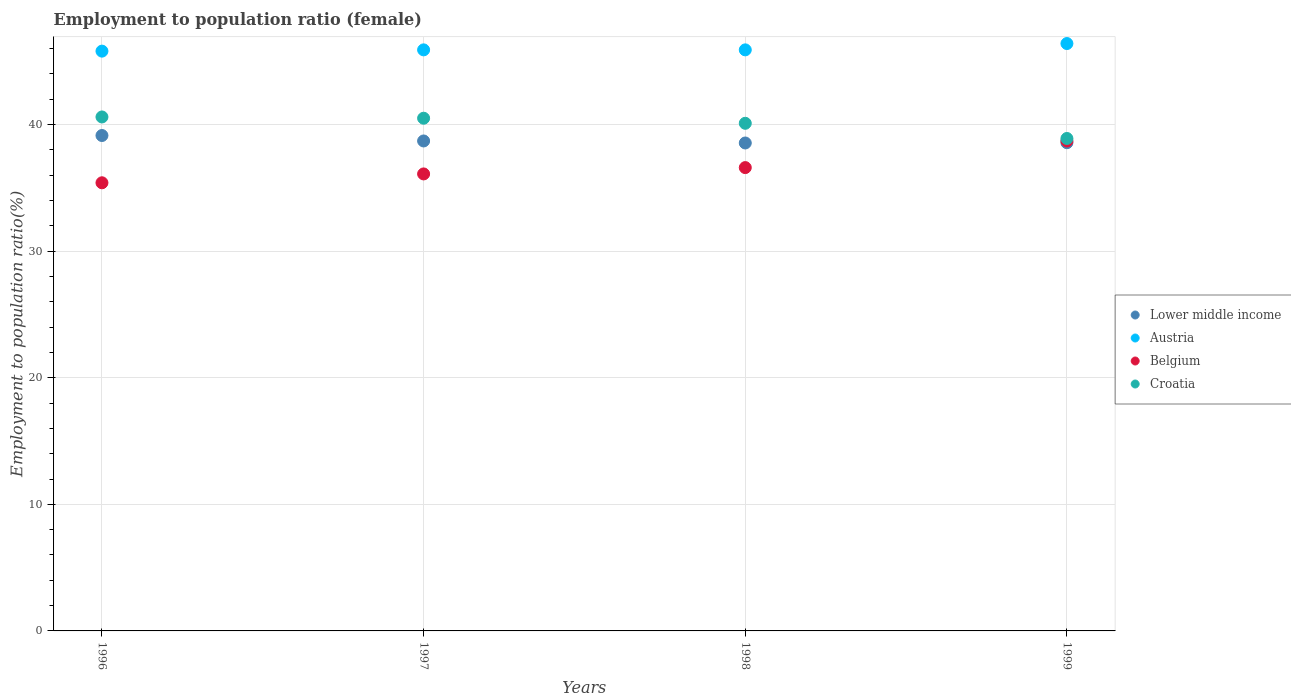What is the employment to population ratio in Croatia in 1998?
Provide a succinct answer. 40.1. Across all years, what is the maximum employment to population ratio in Belgium?
Provide a short and direct response. 38.7. Across all years, what is the minimum employment to population ratio in Lower middle income?
Make the answer very short. 38.54. In which year was the employment to population ratio in Belgium minimum?
Provide a short and direct response. 1996. What is the total employment to population ratio in Lower middle income in the graph?
Keep it short and to the point. 154.95. What is the difference between the employment to population ratio in Austria in 1998 and that in 1999?
Your answer should be very brief. -0.5. What is the difference between the employment to population ratio in Lower middle income in 1998 and the employment to population ratio in Croatia in 1997?
Keep it short and to the point. -1.96. What is the average employment to population ratio in Croatia per year?
Keep it short and to the point. 40.02. In the year 1996, what is the difference between the employment to population ratio in Lower middle income and employment to population ratio in Belgium?
Give a very brief answer. 3.73. What is the ratio of the employment to population ratio in Croatia in 1996 to that in 1999?
Offer a very short reply. 1.04. What is the difference between the highest and the second highest employment to population ratio in Croatia?
Your response must be concise. 0.1. What is the difference between the highest and the lowest employment to population ratio in Croatia?
Make the answer very short. 1.7. In how many years, is the employment to population ratio in Croatia greater than the average employment to population ratio in Croatia taken over all years?
Provide a short and direct response. 3. Is it the case that in every year, the sum of the employment to population ratio in Lower middle income and employment to population ratio in Belgium  is greater than the sum of employment to population ratio in Croatia and employment to population ratio in Austria?
Your answer should be very brief. Yes. Does the employment to population ratio in Lower middle income monotonically increase over the years?
Make the answer very short. No. Is the employment to population ratio in Belgium strictly greater than the employment to population ratio in Lower middle income over the years?
Offer a terse response. No. Is the employment to population ratio in Lower middle income strictly less than the employment to population ratio in Croatia over the years?
Your answer should be compact. Yes. How many dotlines are there?
Your answer should be compact. 4. Are the values on the major ticks of Y-axis written in scientific E-notation?
Ensure brevity in your answer.  No. Does the graph contain any zero values?
Provide a short and direct response. No. Where does the legend appear in the graph?
Offer a terse response. Center right. What is the title of the graph?
Offer a very short reply. Employment to population ratio (female). What is the label or title of the Y-axis?
Give a very brief answer. Employment to population ratio(%). What is the Employment to population ratio(%) in Lower middle income in 1996?
Offer a terse response. 39.13. What is the Employment to population ratio(%) in Austria in 1996?
Give a very brief answer. 45.8. What is the Employment to population ratio(%) of Belgium in 1996?
Keep it short and to the point. 35.4. What is the Employment to population ratio(%) in Croatia in 1996?
Offer a terse response. 40.6. What is the Employment to population ratio(%) in Lower middle income in 1997?
Give a very brief answer. 38.7. What is the Employment to population ratio(%) of Austria in 1997?
Offer a very short reply. 45.9. What is the Employment to population ratio(%) of Belgium in 1997?
Your answer should be compact. 36.1. What is the Employment to population ratio(%) of Croatia in 1997?
Keep it short and to the point. 40.5. What is the Employment to population ratio(%) of Lower middle income in 1998?
Provide a succinct answer. 38.54. What is the Employment to population ratio(%) in Austria in 1998?
Ensure brevity in your answer.  45.9. What is the Employment to population ratio(%) in Belgium in 1998?
Give a very brief answer. 36.6. What is the Employment to population ratio(%) in Croatia in 1998?
Provide a short and direct response. 40.1. What is the Employment to population ratio(%) of Lower middle income in 1999?
Give a very brief answer. 38.57. What is the Employment to population ratio(%) in Austria in 1999?
Offer a terse response. 46.4. What is the Employment to population ratio(%) of Belgium in 1999?
Your answer should be compact. 38.7. What is the Employment to population ratio(%) in Croatia in 1999?
Provide a succinct answer. 38.9. Across all years, what is the maximum Employment to population ratio(%) in Lower middle income?
Offer a terse response. 39.13. Across all years, what is the maximum Employment to population ratio(%) in Austria?
Offer a terse response. 46.4. Across all years, what is the maximum Employment to population ratio(%) in Belgium?
Your answer should be compact. 38.7. Across all years, what is the maximum Employment to population ratio(%) of Croatia?
Offer a very short reply. 40.6. Across all years, what is the minimum Employment to population ratio(%) in Lower middle income?
Keep it short and to the point. 38.54. Across all years, what is the minimum Employment to population ratio(%) of Austria?
Offer a very short reply. 45.8. Across all years, what is the minimum Employment to population ratio(%) of Belgium?
Provide a succinct answer. 35.4. Across all years, what is the minimum Employment to population ratio(%) in Croatia?
Your answer should be compact. 38.9. What is the total Employment to population ratio(%) in Lower middle income in the graph?
Ensure brevity in your answer.  154.95. What is the total Employment to population ratio(%) of Austria in the graph?
Your response must be concise. 184. What is the total Employment to population ratio(%) of Belgium in the graph?
Keep it short and to the point. 146.8. What is the total Employment to population ratio(%) in Croatia in the graph?
Give a very brief answer. 160.1. What is the difference between the Employment to population ratio(%) of Lower middle income in 1996 and that in 1997?
Give a very brief answer. 0.43. What is the difference between the Employment to population ratio(%) in Belgium in 1996 and that in 1997?
Your response must be concise. -0.7. What is the difference between the Employment to population ratio(%) in Croatia in 1996 and that in 1997?
Your answer should be compact. 0.1. What is the difference between the Employment to population ratio(%) in Lower middle income in 1996 and that in 1998?
Your response must be concise. 0.59. What is the difference between the Employment to population ratio(%) of Lower middle income in 1996 and that in 1999?
Provide a succinct answer. 0.57. What is the difference between the Employment to population ratio(%) in Austria in 1996 and that in 1999?
Keep it short and to the point. -0.6. What is the difference between the Employment to population ratio(%) of Belgium in 1996 and that in 1999?
Your response must be concise. -3.3. What is the difference between the Employment to population ratio(%) in Croatia in 1996 and that in 1999?
Offer a terse response. 1.7. What is the difference between the Employment to population ratio(%) in Lower middle income in 1997 and that in 1998?
Your answer should be very brief. 0.16. What is the difference between the Employment to population ratio(%) in Belgium in 1997 and that in 1998?
Provide a succinct answer. -0.5. What is the difference between the Employment to population ratio(%) in Croatia in 1997 and that in 1998?
Make the answer very short. 0.4. What is the difference between the Employment to population ratio(%) of Lower middle income in 1997 and that in 1999?
Offer a terse response. 0.14. What is the difference between the Employment to population ratio(%) in Belgium in 1997 and that in 1999?
Your response must be concise. -2.6. What is the difference between the Employment to population ratio(%) of Croatia in 1997 and that in 1999?
Your response must be concise. 1.6. What is the difference between the Employment to population ratio(%) of Lower middle income in 1998 and that in 1999?
Give a very brief answer. -0.02. What is the difference between the Employment to population ratio(%) of Austria in 1998 and that in 1999?
Your answer should be compact. -0.5. What is the difference between the Employment to population ratio(%) of Belgium in 1998 and that in 1999?
Keep it short and to the point. -2.1. What is the difference between the Employment to population ratio(%) of Croatia in 1998 and that in 1999?
Ensure brevity in your answer.  1.2. What is the difference between the Employment to population ratio(%) of Lower middle income in 1996 and the Employment to population ratio(%) of Austria in 1997?
Ensure brevity in your answer.  -6.77. What is the difference between the Employment to population ratio(%) in Lower middle income in 1996 and the Employment to population ratio(%) in Belgium in 1997?
Your answer should be very brief. 3.03. What is the difference between the Employment to population ratio(%) of Lower middle income in 1996 and the Employment to population ratio(%) of Croatia in 1997?
Make the answer very short. -1.37. What is the difference between the Employment to population ratio(%) in Austria in 1996 and the Employment to population ratio(%) in Croatia in 1997?
Give a very brief answer. 5.3. What is the difference between the Employment to population ratio(%) of Lower middle income in 1996 and the Employment to population ratio(%) of Austria in 1998?
Offer a terse response. -6.77. What is the difference between the Employment to population ratio(%) of Lower middle income in 1996 and the Employment to population ratio(%) of Belgium in 1998?
Keep it short and to the point. 2.53. What is the difference between the Employment to population ratio(%) in Lower middle income in 1996 and the Employment to population ratio(%) in Croatia in 1998?
Offer a terse response. -0.97. What is the difference between the Employment to population ratio(%) of Austria in 1996 and the Employment to population ratio(%) of Belgium in 1998?
Offer a very short reply. 9.2. What is the difference between the Employment to population ratio(%) of Lower middle income in 1996 and the Employment to population ratio(%) of Austria in 1999?
Provide a succinct answer. -7.27. What is the difference between the Employment to population ratio(%) in Lower middle income in 1996 and the Employment to population ratio(%) in Belgium in 1999?
Keep it short and to the point. 0.43. What is the difference between the Employment to population ratio(%) in Lower middle income in 1996 and the Employment to population ratio(%) in Croatia in 1999?
Your answer should be very brief. 0.23. What is the difference between the Employment to population ratio(%) of Austria in 1996 and the Employment to population ratio(%) of Belgium in 1999?
Your response must be concise. 7.1. What is the difference between the Employment to population ratio(%) of Belgium in 1996 and the Employment to population ratio(%) of Croatia in 1999?
Keep it short and to the point. -3.5. What is the difference between the Employment to population ratio(%) in Lower middle income in 1997 and the Employment to population ratio(%) in Austria in 1998?
Ensure brevity in your answer.  -7.2. What is the difference between the Employment to population ratio(%) in Lower middle income in 1997 and the Employment to population ratio(%) in Belgium in 1998?
Ensure brevity in your answer.  2.1. What is the difference between the Employment to population ratio(%) in Lower middle income in 1997 and the Employment to population ratio(%) in Croatia in 1998?
Keep it short and to the point. -1.4. What is the difference between the Employment to population ratio(%) in Austria in 1997 and the Employment to population ratio(%) in Belgium in 1998?
Your answer should be compact. 9.3. What is the difference between the Employment to population ratio(%) of Belgium in 1997 and the Employment to population ratio(%) of Croatia in 1998?
Provide a succinct answer. -4. What is the difference between the Employment to population ratio(%) of Lower middle income in 1997 and the Employment to population ratio(%) of Austria in 1999?
Your response must be concise. -7.7. What is the difference between the Employment to population ratio(%) in Lower middle income in 1997 and the Employment to population ratio(%) in Belgium in 1999?
Offer a very short reply. 0. What is the difference between the Employment to population ratio(%) in Lower middle income in 1997 and the Employment to population ratio(%) in Croatia in 1999?
Keep it short and to the point. -0.2. What is the difference between the Employment to population ratio(%) of Austria in 1997 and the Employment to population ratio(%) of Croatia in 1999?
Offer a terse response. 7. What is the difference between the Employment to population ratio(%) of Belgium in 1997 and the Employment to population ratio(%) of Croatia in 1999?
Provide a succinct answer. -2.8. What is the difference between the Employment to population ratio(%) of Lower middle income in 1998 and the Employment to population ratio(%) of Austria in 1999?
Your answer should be very brief. -7.86. What is the difference between the Employment to population ratio(%) in Lower middle income in 1998 and the Employment to population ratio(%) in Belgium in 1999?
Provide a succinct answer. -0.16. What is the difference between the Employment to population ratio(%) of Lower middle income in 1998 and the Employment to population ratio(%) of Croatia in 1999?
Provide a short and direct response. -0.36. What is the difference between the Employment to population ratio(%) in Austria in 1998 and the Employment to population ratio(%) in Belgium in 1999?
Your response must be concise. 7.2. What is the difference between the Employment to population ratio(%) of Austria in 1998 and the Employment to population ratio(%) of Croatia in 1999?
Ensure brevity in your answer.  7. What is the average Employment to population ratio(%) of Lower middle income per year?
Your answer should be very brief. 38.74. What is the average Employment to population ratio(%) of Austria per year?
Your answer should be compact. 46. What is the average Employment to population ratio(%) of Belgium per year?
Ensure brevity in your answer.  36.7. What is the average Employment to population ratio(%) of Croatia per year?
Make the answer very short. 40.02. In the year 1996, what is the difference between the Employment to population ratio(%) in Lower middle income and Employment to population ratio(%) in Austria?
Offer a terse response. -6.67. In the year 1996, what is the difference between the Employment to population ratio(%) of Lower middle income and Employment to population ratio(%) of Belgium?
Offer a very short reply. 3.73. In the year 1996, what is the difference between the Employment to population ratio(%) of Lower middle income and Employment to population ratio(%) of Croatia?
Make the answer very short. -1.47. In the year 1996, what is the difference between the Employment to population ratio(%) of Austria and Employment to population ratio(%) of Belgium?
Ensure brevity in your answer.  10.4. In the year 1996, what is the difference between the Employment to population ratio(%) in Austria and Employment to population ratio(%) in Croatia?
Make the answer very short. 5.2. In the year 1997, what is the difference between the Employment to population ratio(%) of Lower middle income and Employment to population ratio(%) of Austria?
Provide a short and direct response. -7.2. In the year 1997, what is the difference between the Employment to population ratio(%) of Lower middle income and Employment to population ratio(%) of Belgium?
Give a very brief answer. 2.6. In the year 1997, what is the difference between the Employment to population ratio(%) of Lower middle income and Employment to population ratio(%) of Croatia?
Provide a short and direct response. -1.8. In the year 1998, what is the difference between the Employment to population ratio(%) in Lower middle income and Employment to population ratio(%) in Austria?
Give a very brief answer. -7.36. In the year 1998, what is the difference between the Employment to population ratio(%) of Lower middle income and Employment to population ratio(%) of Belgium?
Give a very brief answer. 1.94. In the year 1998, what is the difference between the Employment to population ratio(%) in Lower middle income and Employment to population ratio(%) in Croatia?
Offer a very short reply. -1.56. In the year 1998, what is the difference between the Employment to population ratio(%) in Austria and Employment to population ratio(%) in Belgium?
Provide a short and direct response. 9.3. In the year 1998, what is the difference between the Employment to population ratio(%) of Austria and Employment to population ratio(%) of Croatia?
Your response must be concise. 5.8. In the year 1999, what is the difference between the Employment to population ratio(%) of Lower middle income and Employment to population ratio(%) of Austria?
Your answer should be very brief. -7.83. In the year 1999, what is the difference between the Employment to population ratio(%) of Lower middle income and Employment to population ratio(%) of Belgium?
Ensure brevity in your answer.  -0.13. In the year 1999, what is the difference between the Employment to population ratio(%) in Lower middle income and Employment to population ratio(%) in Croatia?
Ensure brevity in your answer.  -0.33. In the year 1999, what is the difference between the Employment to population ratio(%) of Belgium and Employment to population ratio(%) of Croatia?
Make the answer very short. -0.2. What is the ratio of the Employment to population ratio(%) in Lower middle income in 1996 to that in 1997?
Offer a very short reply. 1.01. What is the ratio of the Employment to population ratio(%) of Austria in 1996 to that in 1997?
Provide a succinct answer. 1. What is the ratio of the Employment to population ratio(%) in Belgium in 1996 to that in 1997?
Your answer should be compact. 0.98. What is the ratio of the Employment to population ratio(%) of Croatia in 1996 to that in 1997?
Offer a terse response. 1. What is the ratio of the Employment to population ratio(%) of Lower middle income in 1996 to that in 1998?
Your answer should be very brief. 1.02. What is the ratio of the Employment to population ratio(%) of Belgium in 1996 to that in 1998?
Your answer should be compact. 0.97. What is the ratio of the Employment to population ratio(%) in Croatia in 1996 to that in 1998?
Your response must be concise. 1.01. What is the ratio of the Employment to population ratio(%) in Lower middle income in 1996 to that in 1999?
Make the answer very short. 1.01. What is the ratio of the Employment to population ratio(%) of Austria in 1996 to that in 1999?
Keep it short and to the point. 0.99. What is the ratio of the Employment to population ratio(%) in Belgium in 1996 to that in 1999?
Your answer should be compact. 0.91. What is the ratio of the Employment to population ratio(%) in Croatia in 1996 to that in 1999?
Your response must be concise. 1.04. What is the ratio of the Employment to population ratio(%) in Lower middle income in 1997 to that in 1998?
Make the answer very short. 1. What is the ratio of the Employment to population ratio(%) of Austria in 1997 to that in 1998?
Ensure brevity in your answer.  1. What is the ratio of the Employment to population ratio(%) of Belgium in 1997 to that in 1998?
Keep it short and to the point. 0.99. What is the ratio of the Employment to population ratio(%) of Croatia in 1997 to that in 1998?
Make the answer very short. 1.01. What is the ratio of the Employment to population ratio(%) in Lower middle income in 1997 to that in 1999?
Provide a succinct answer. 1. What is the ratio of the Employment to population ratio(%) of Belgium in 1997 to that in 1999?
Offer a very short reply. 0.93. What is the ratio of the Employment to population ratio(%) in Croatia in 1997 to that in 1999?
Ensure brevity in your answer.  1.04. What is the ratio of the Employment to population ratio(%) in Lower middle income in 1998 to that in 1999?
Your response must be concise. 1. What is the ratio of the Employment to population ratio(%) of Austria in 1998 to that in 1999?
Offer a terse response. 0.99. What is the ratio of the Employment to population ratio(%) in Belgium in 1998 to that in 1999?
Your answer should be compact. 0.95. What is the ratio of the Employment to population ratio(%) in Croatia in 1998 to that in 1999?
Ensure brevity in your answer.  1.03. What is the difference between the highest and the second highest Employment to population ratio(%) in Lower middle income?
Provide a succinct answer. 0.43. What is the difference between the highest and the second highest Employment to population ratio(%) in Austria?
Keep it short and to the point. 0.5. What is the difference between the highest and the lowest Employment to population ratio(%) in Lower middle income?
Your answer should be very brief. 0.59. 